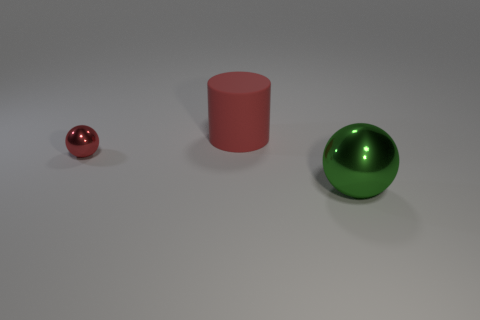Can you tell me what colors are present in the three objects? Certainly! There are three objects, each with its own distinct color. The smallest object appears to be a shiny, reflective red sphere, the medium-sized object is a matte, solid red cylinder, and the largest is a shiny green sphere. 